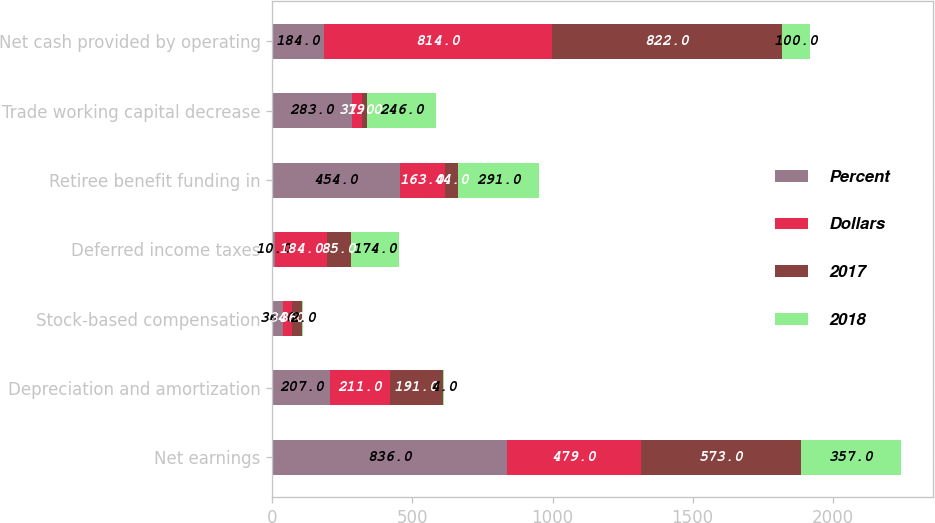Convert chart to OTSL. <chart><loc_0><loc_0><loc_500><loc_500><stacked_bar_chart><ecel><fcel>Net earnings<fcel>Depreciation and amortization<fcel>Stock-based compensation<fcel>Deferred income taxes<fcel>Retiree benefit funding in<fcel>Trade working capital decrease<fcel>Net cash provided by operating<nl><fcel>Percent<fcel>836<fcel>207<fcel>36<fcel>10<fcel>454<fcel>283<fcel>184<nl><fcel>Dollars<fcel>479<fcel>211<fcel>34<fcel>184<fcel>163<fcel>37<fcel>814<nl><fcel>2017<fcel>573<fcel>191<fcel>36<fcel>85<fcel>44<fcel>19<fcel>822<nl><fcel>2018<fcel>357<fcel>4<fcel>2<fcel>174<fcel>291<fcel>246<fcel>100<nl></chart> 